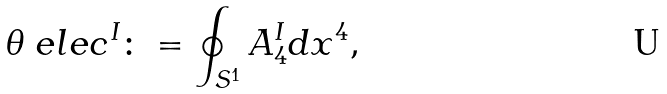Convert formula to latex. <formula><loc_0><loc_0><loc_500><loc_500>\theta _ { \ } e l e c ^ { I } \colon = \oint _ { S ^ { 1 } } A _ { 4 } ^ { I } d x ^ { 4 } ,</formula> 